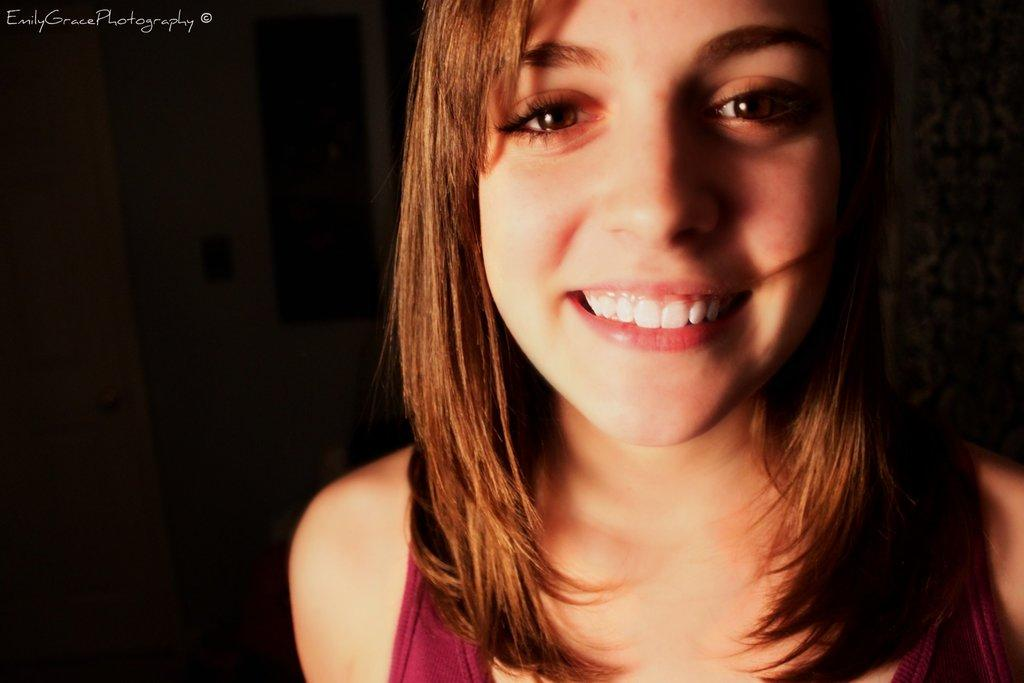Who is present in the image? There is a lady in the image. What can be seen in the background of the image? There is a wall with some objects in the background. Is there any entrance or exit visible in the image? Yes, there is a door visible in the image. What is located in the top left corner of the image? There is some text in the top left corner of the image. What invention is being showcased in the image? There is no invention being showcased in the image; it primarily features a lady and some background elements. 